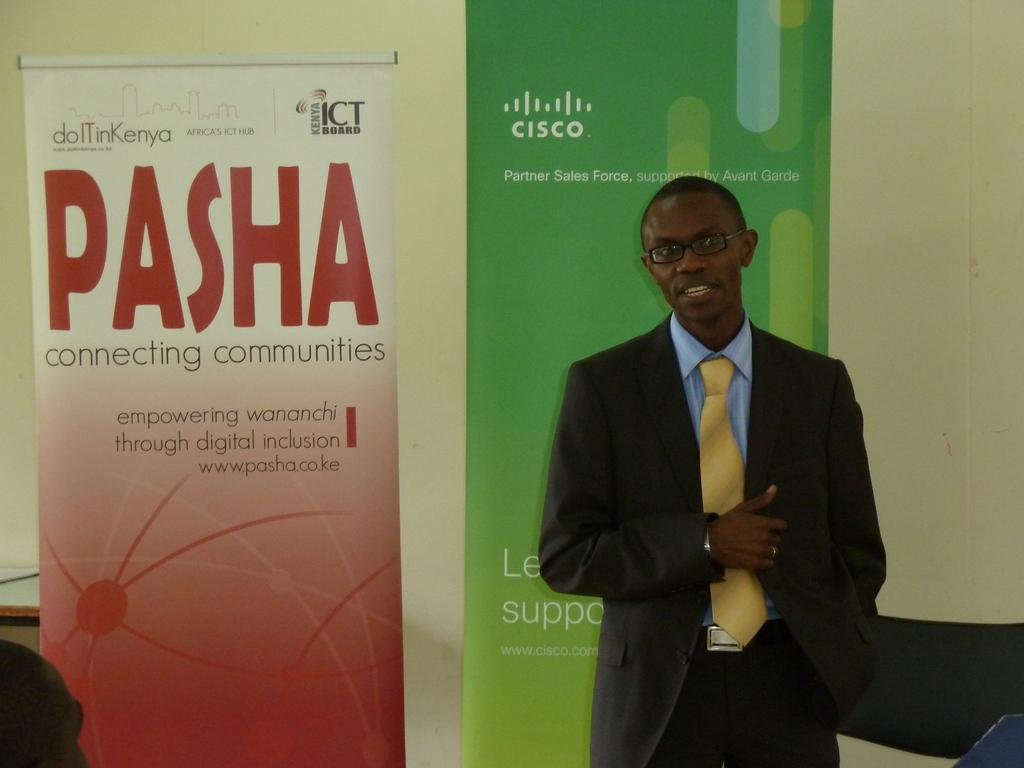<image>
Offer a succinct explanation of the picture presented. A man in a suit stands in front of signs promoting Cisco and Pasha. 